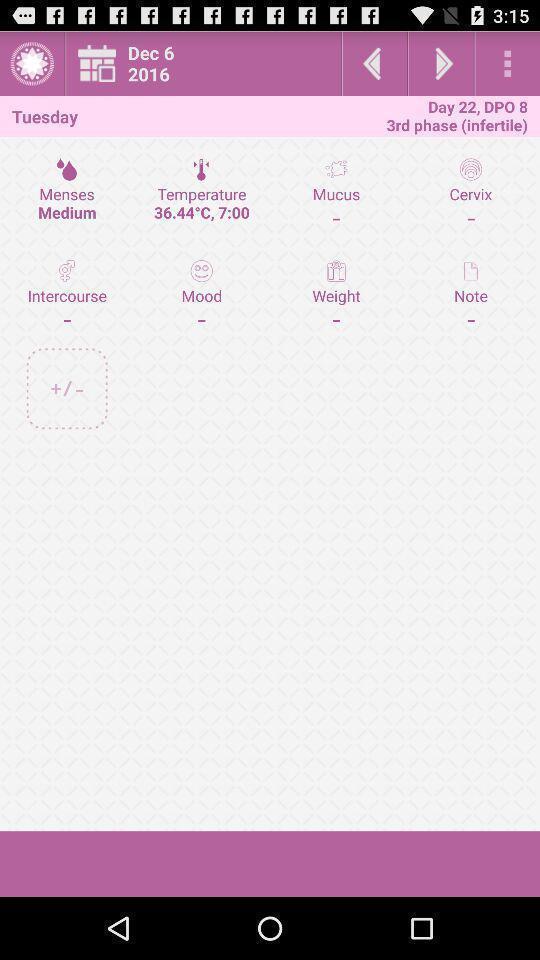Describe the content in this image. Page with multiple options. 